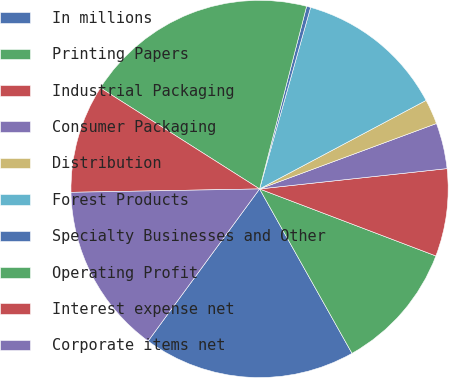Convert chart to OTSL. <chart><loc_0><loc_0><loc_500><loc_500><pie_chart><fcel>In millions<fcel>Printing Papers<fcel>Industrial Packaging<fcel>Consumer Packaging<fcel>Distribution<fcel>Forest Products<fcel>Specialty Businesses and Other<fcel>Operating Profit<fcel>Interest expense net<fcel>Corporate items net<nl><fcel>18.22%<fcel>11.07%<fcel>7.5%<fcel>3.92%<fcel>2.14%<fcel>12.86%<fcel>0.35%<fcel>20.01%<fcel>9.29%<fcel>14.65%<nl></chart> 